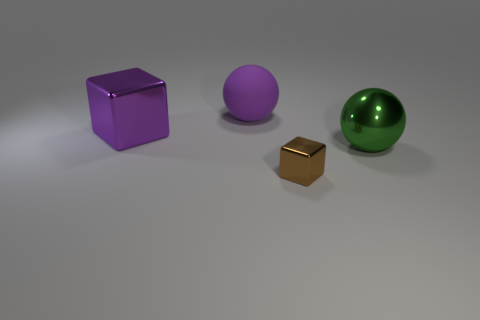There is a large rubber object; is its color the same as the large metallic object that is to the left of the metal sphere?
Your answer should be very brief. Yes. There is a metal block behind the green ball; does it have the same color as the large matte thing?
Ensure brevity in your answer.  Yes. There is a big ball that is the same color as the big metal block; what material is it?
Give a very brief answer. Rubber. Is there a object of the same color as the large matte ball?
Offer a terse response. Yes. Is there any other thing that has the same size as the brown object?
Give a very brief answer. No. There is a big metallic object that is on the left side of the purple thing to the right of the metallic block to the left of the brown object; what color is it?
Offer a terse response. Purple. What number of things are both behind the green shiny thing and right of the purple block?
Keep it short and to the point. 1. How many cylinders are small metal things or purple things?
Ensure brevity in your answer.  0. Are there any large green metallic objects?
Keep it short and to the point. Yes. How many other things are there of the same material as the brown object?
Your answer should be compact. 2. 